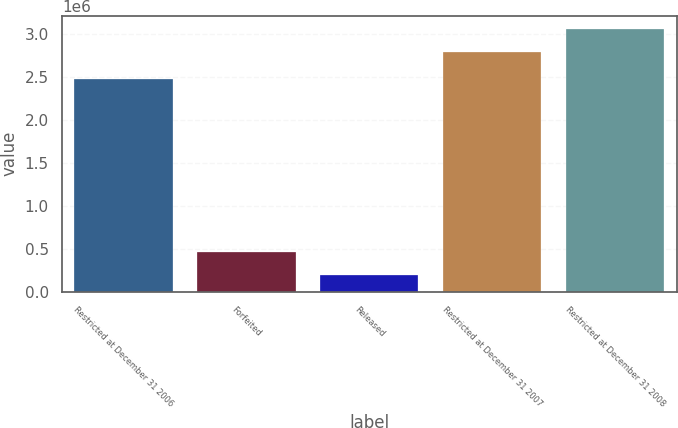<chart> <loc_0><loc_0><loc_500><loc_500><bar_chart><fcel>Restricted at December 31 2006<fcel>Forfeited<fcel>Released<fcel>Restricted at December 31 2007<fcel>Restricted at December 31 2008<nl><fcel>2.475e+06<fcel>465535<fcel>198956<fcel>2.79336e+06<fcel>3.05994e+06<nl></chart> 